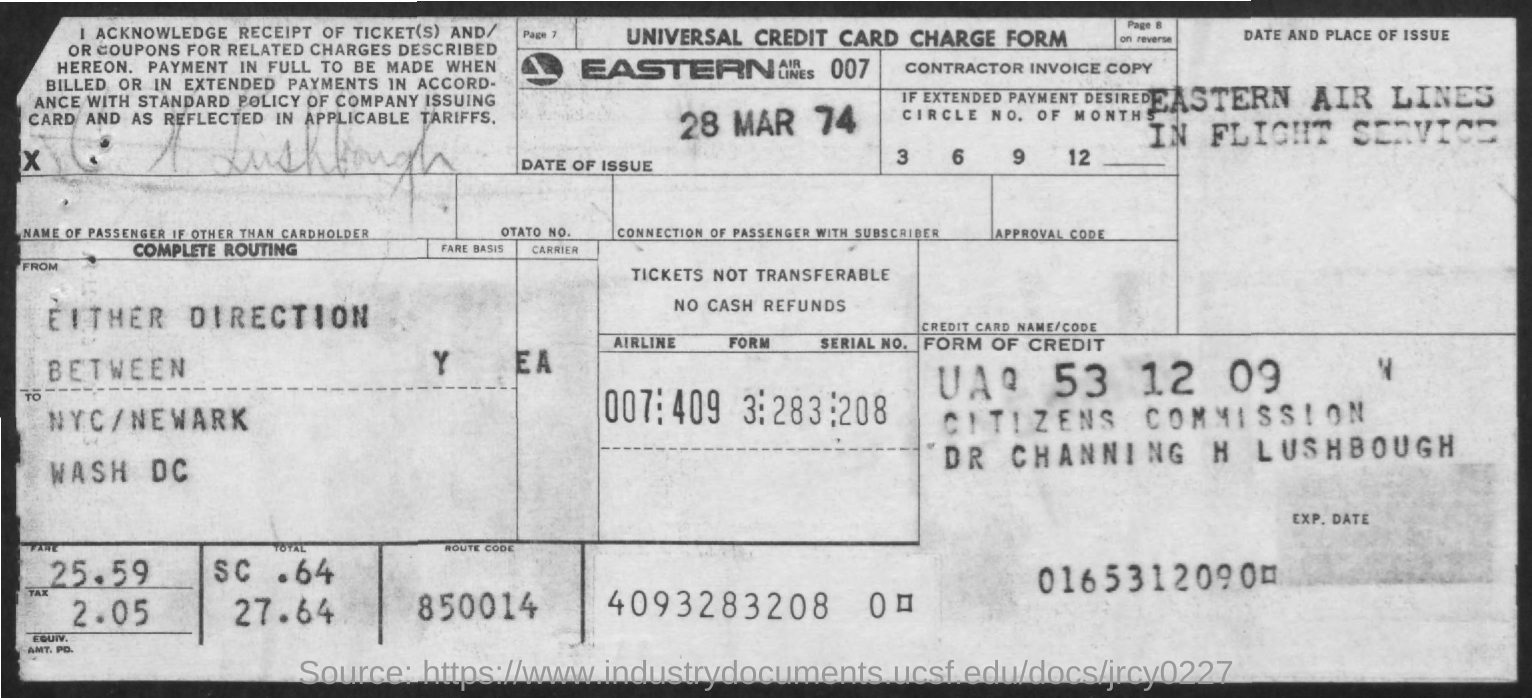What is the fare?
Ensure brevity in your answer.  25.59. What is the tax amount?
Your answer should be very brief. 2.05. What is the route code?
Your response must be concise. 850014. What is the date of the issue?
Your answer should be very brief. 28 mar 74. What is the name of the Airline?
Provide a succinct answer. Eastern Airlines. 